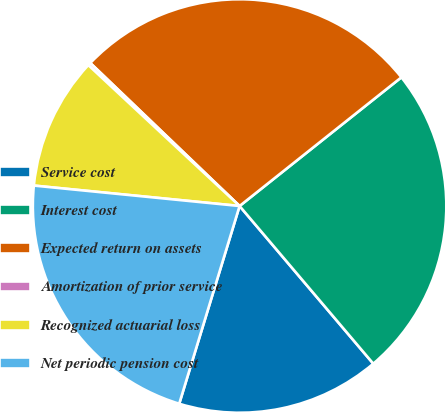Convert chart to OTSL. <chart><loc_0><loc_0><loc_500><loc_500><pie_chart><fcel>Service cost<fcel>Interest cost<fcel>Expected return on assets<fcel>Amortization of prior service<fcel>Recognized actuarial loss<fcel>Net periodic pension cost<nl><fcel>15.91%<fcel>24.5%<fcel>27.15%<fcel>0.22%<fcel>10.36%<fcel>21.86%<nl></chart> 